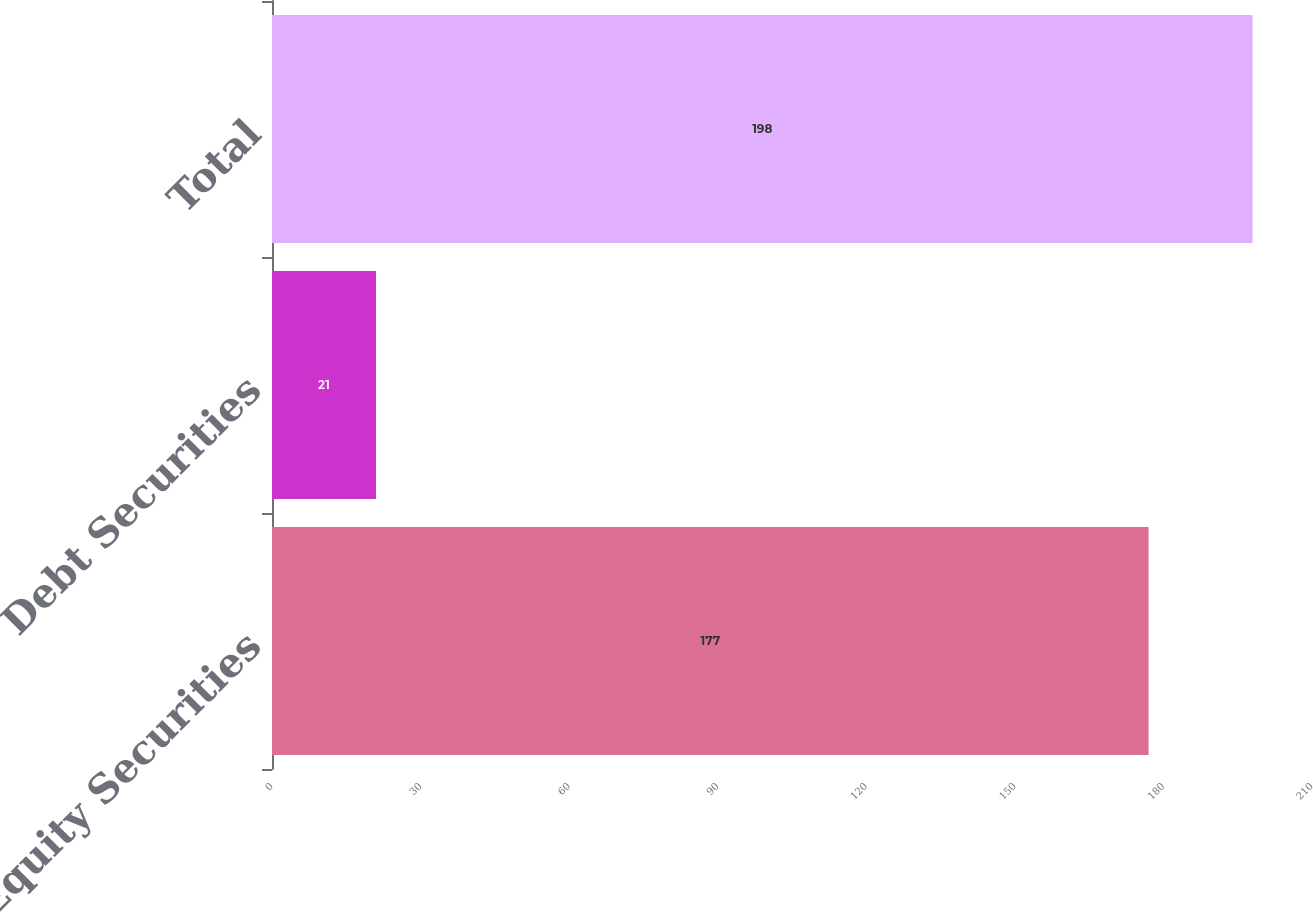Convert chart to OTSL. <chart><loc_0><loc_0><loc_500><loc_500><bar_chart><fcel>Equity Securities<fcel>Debt Securities<fcel>Total<nl><fcel>177<fcel>21<fcel>198<nl></chart> 